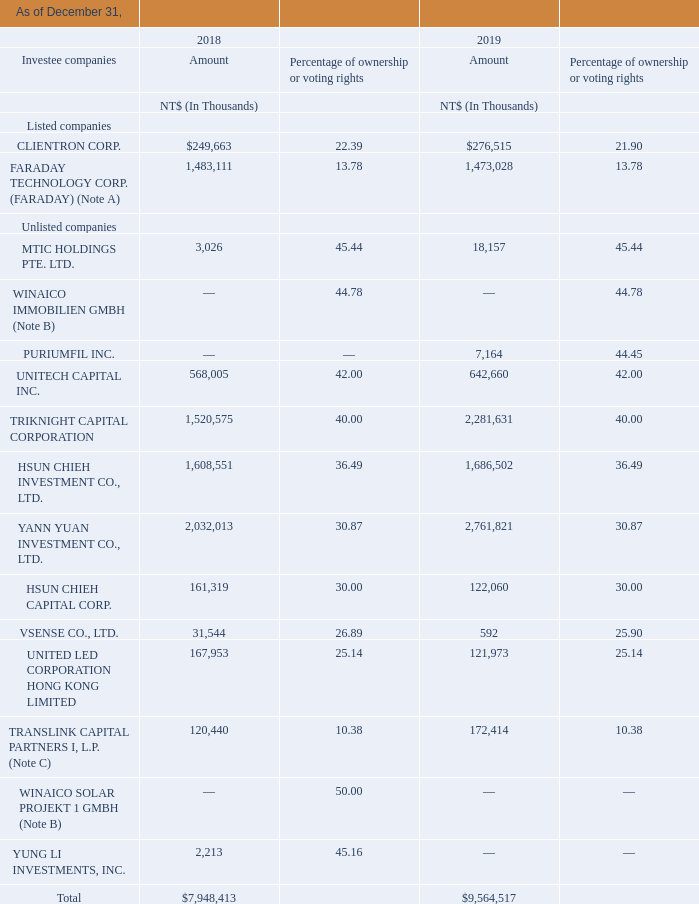Note A: Beginning from June 2015, the Company accounts for its investment in FARADAY as an associate given the fact that the Company obtained the ability to exercise significant influence over FARADAY through representation on its Board of Directors.
Note B: WINAICO SOLAR PROJEKT 1 GMBH and WINAICO IMMOBILIEN GMBH are joint ventures to the Company.
Note C: The Company follows international accounting practices in equity accounting for limited partnerships and uses the equity method to account for these investees.
The carrying amount of investments accounted for using the equity method for which there are published price quotations amounted to NT$1,733 million and NT$1,750 million, as of December 31, 2018 and 2019, respectively. The fair value of these investments were NT$1,621 million and NT$2,244 million, as of December 31, 2018 and 2019, respectively.
What accounting practices is used by the company in equity accounting? International accounting practices. What was the price quotation for investments as of 31 December 2018? Nt$1,733 million. What was the fair value for investments as of 31 December 2018 ? Nt$1,621 million. What is the average amount of investments of listed companies in 2018?
Answer scale should be: thousand. (249,663+1,483,111) / 2
Answer: 866387. What is the average amount of investments of listed companies in 2019?
Answer scale should be: thousand. (276,515+1,473,028) / 2
Answer: 874771.5. What is the average Percentage of ownership or voting rights of listed companies in 2019?
Answer scale should be: percent. (21.9+13.78) / 2
Answer: 17.84. 